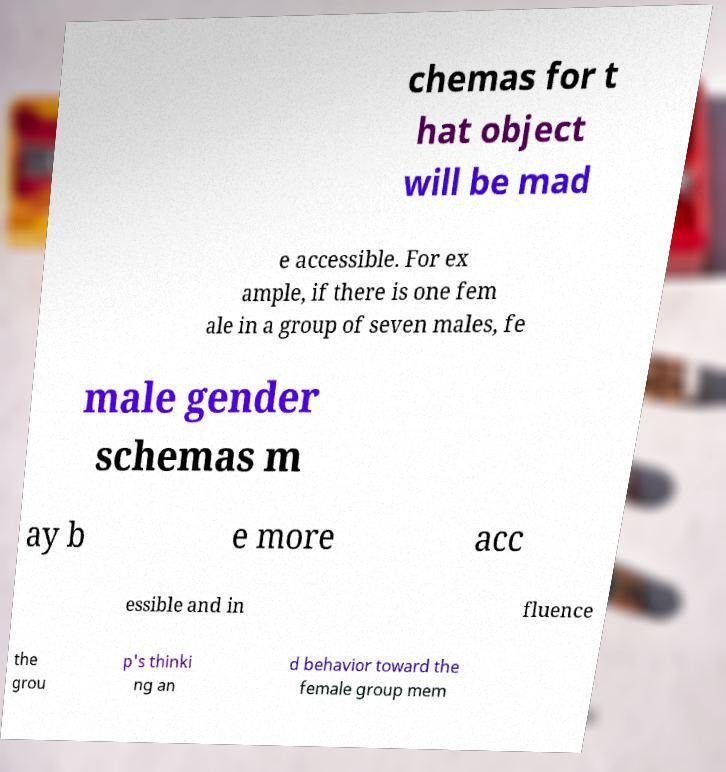Can you accurately transcribe the text from the provided image for me? chemas for t hat object will be mad e accessible. For ex ample, if there is one fem ale in a group of seven males, fe male gender schemas m ay b e more acc essible and in fluence the grou p's thinki ng an d behavior toward the female group mem 